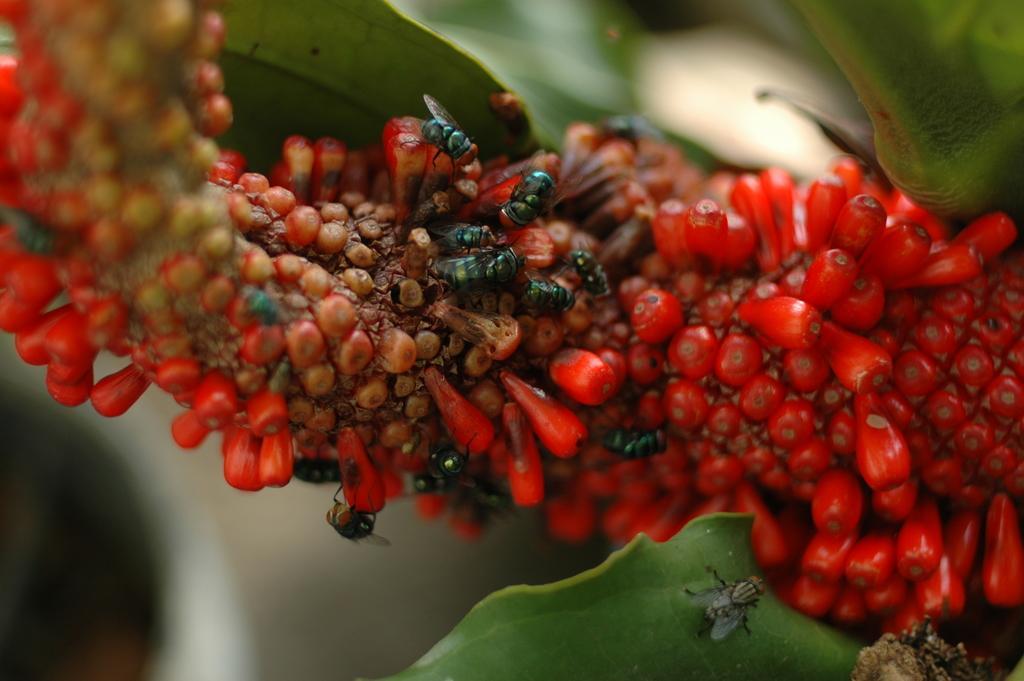In one or two sentences, can you explain what this image depicts? In the picture we can see a plant with some red color fruits to it and on it we can see house flies eating it and besides it we can see some leaves. 